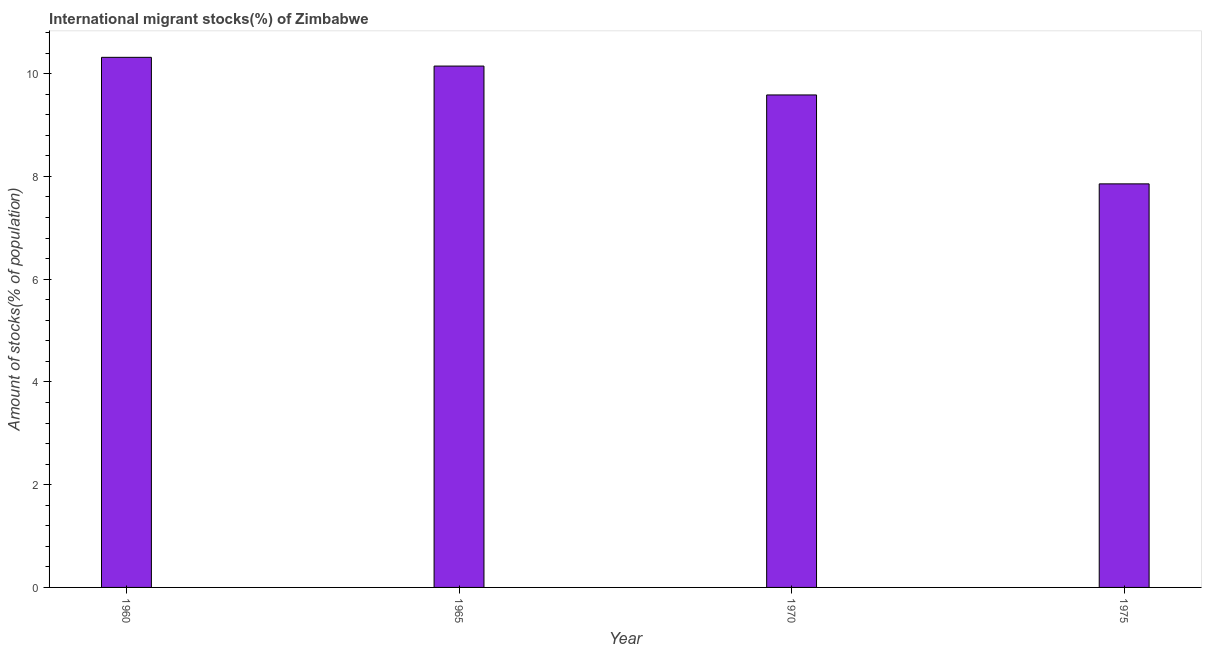Does the graph contain grids?
Provide a short and direct response. No. What is the title of the graph?
Offer a very short reply. International migrant stocks(%) of Zimbabwe. What is the label or title of the X-axis?
Your answer should be compact. Year. What is the label or title of the Y-axis?
Your answer should be very brief. Amount of stocks(% of population). What is the number of international migrant stocks in 1960?
Offer a very short reply. 10.32. Across all years, what is the maximum number of international migrant stocks?
Your answer should be very brief. 10.32. Across all years, what is the minimum number of international migrant stocks?
Your answer should be very brief. 7.86. In which year was the number of international migrant stocks maximum?
Provide a short and direct response. 1960. In which year was the number of international migrant stocks minimum?
Your answer should be compact. 1975. What is the sum of the number of international migrant stocks?
Keep it short and to the point. 37.91. What is the difference between the number of international migrant stocks in 1960 and 1965?
Offer a terse response. 0.17. What is the average number of international migrant stocks per year?
Ensure brevity in your answer.  9.48. What is the median number of international migrant stocks?
Ensure brevity in your answer.  9.87. In how many years, is the number of international migrant stocks greater than 5.6 %?
Offer a terse response. 4. Do a majority of the years between 1975 and 1960 (inclusive) have number of international migrant stocks greater than 2.8 %?
Your answer should be compact. Yes. What is the ratio of the number of international migrant stocks in 1960 to that in 1965?
Provide a succinct answer. 1.02. What is the difference between the highest and the second highest number of international migrant stocks?
Keep it short and to the point. 0.17. What is the difference between the highest and the lowest number of international migrant stocks?
Offer a terse response. 2.46. In how many years, is the number of international migrant stocks greater than the average number of international migrant stocks taken over all years?
Keep it short and to the point. 3. How many years are there in the graph?
Offer a terse response. 4. Are the values on the major ticks of Y-axis written in scientific E-notation?
Make the answer very short. No. What is the Amount of stocks(% of population) of 1960?
Offer a terse response. 10.32. What is the Amount of stocks(% of population) of 1965?
Offer a terse response. 10.15. What is the Amount of stocks(% of population) in 1970?
Your answer should be compact. 9.59. What is the Amount of stocks(% of population) in 1975?
Provide a succinct answer. 7.86. What is the difference between the Amount of stocks(% of population) in 1960 and 1965?
Give a very brief answer. 0.17. What is the difference between the Amount of stocks(% of population) in 1960 and 1970?
Offer a terse response. 0.73. What is the difference between the Amount of stocks(% of population) in 1960 and 1975?
Your response must be concise. 2.46. What is the difference between the Amount of stocks(% of population) in 1965 and 1970?
Your response must be concise. 0.56. What is the difference between the Amount of stocks(% of population) in 1965 and 1975?
Give a very brief answer. 2.29. What is the difference between the Amount of stocks(% of population) in 1970 and 1975?
Keep it short and to the point. 1.73. What is the ratio of the Amount of stocks(% of population) in 1960 to that in 1970?
Make the answer very short. 1.08. What is the ratio of the Amount of stocks(% of population) in 1960 to that in 1975?
Give a very brief answer. 1.31. What is the ratio of the Amount of stocks(% of population) in 1965 to that in 1970?
Your answer should be compact. 1.06. What is the ratio of the Amount of stocks(% of population) in 1965 to that in 1975?
Offer a terse response. 1.29. What is the ratio of the Amount of stocks(% of population) in 1970 to that in 1975?
Your response must be concise. 1.22. 